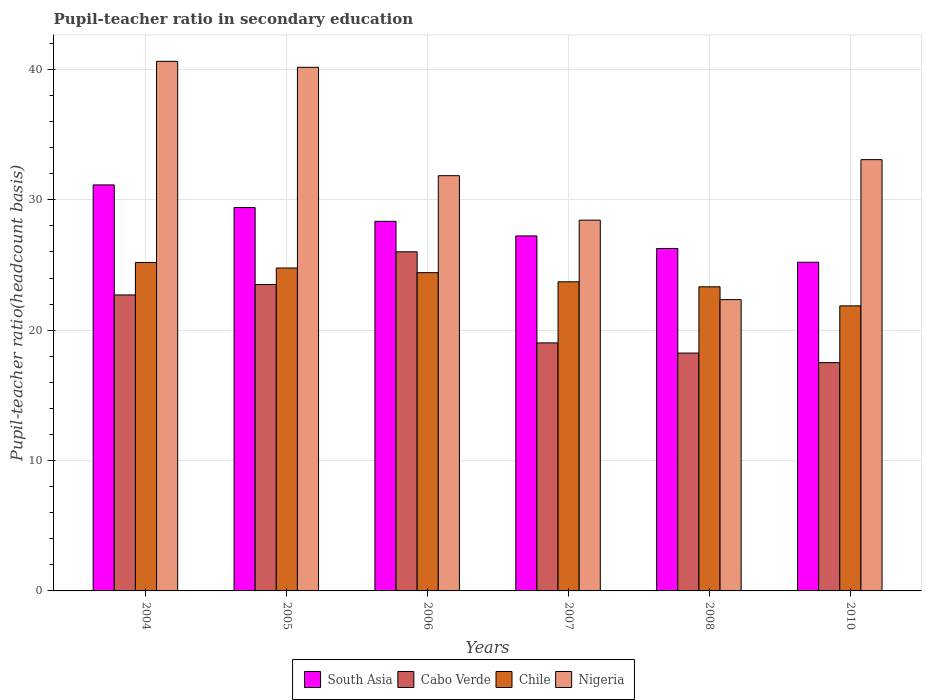How many groups of bars are there?
Offer a terse response. 6. Are the number of bars per tick equal to the number of legend labels?
Your response must be concise. Yes. Are the number of bars on each tick of the X-axis equal?
Your answer should be compact. Yes. How many bars are there on the 3rd tick from the left?
Your answer should be compact. 4. How many bars are there on the 3rd tick from the right?
Your answer should be compact. 4. What is the pupil-teacher ratio in secondary education in Cabo Verde in 2006?
Your answer should be very brief. 26.01. Across all years, what is the maximum pupil-teacher ratio in secondary education in Cabo Verde?
Your answer should be very brief. 26.01. Across all years, what is the minimum pupil-teacher ratio in secondary education in Chile?
Make the answer very short. 21.87. In which year was the pupil-teacher ratio in secondary education in South Asia maximum?
Provide a short and direct response. 2004. What is the total pupil-teacher ratio in secondary education in Chile in the graph?
Offer a very short reply. 143.28. What is the difference between the pupil-teacher ratio in secondary education in Nigeria in 2006 and that in 2008?
Make the answer very short. 9.51. What is the difference between the pupil-teacher ratio in secondary education in Nigeria in 2007 and the pupil-teacher ratio in secondary education in Cabo Verde in 2005?
Give a very brief answer. 4.94. What is the average pupil-teacher ratio in secondary education in Nigeria per year?
Your answer should be compact. 32.75. In the year 2004, what is the difference between the pupil-teacher ratio in secondary education in Chile and pupil-teacher ratio in secondary education in Nigeria?
Your answer should be compact. -15.43. In how many years, is the pupil-teacher ratio in secondary education in Nigeria greater than 38?
Offer a very short reply. 2. What is the ratio of the pupil-teacher ratio in secondary education in Cabo Verde in 2005 to that in 2006?
Offer a very short reply. 0.9. Is the pupil-teacher ratio in secondary education in South Asia in 2006 less than that in 2007?
Ensure brevity in your answer.  No. Is the difference between the pupil-teacher ratio in secondary education in Chile in 2006 and 2008 greater than the difference between the pupil-teacher ratio in secondary education in Nigeria in 2006 and 2008?
Provide a short and direct response. No. What is the difference between the highest and the second highest pupil-teacher ratio in secondary education in Cabo Verde?
Keep it short and to the point. 2.51. What is the difference between the highest and the lowest pupil-teacher ratio in secondary education in Chile?
Your answer should be compact. 3.33. What does the 4th bar from the left in 2010 represents?
Your response must be concise. Nigeria. Is it the case that in every year, the sum of the pupil-teacher ratio in secondary education in South Asia and pupil-teacher ratio in secondary education in Cabo Verde is greater than the pupil-teacher ratio in secondary education in Chile?
Keep it short and to the point. Yes. How many bars are there?
Give a very brief answer. 24. Are all the bars in the graph horizontal?
Provide a short and direct response. No. What is the difference between two consecutive major ticks on the Y-axis?
Keep it short and to the point. 10. Are the values on the major ticks of Y-axis written in scientific E-notation?
Provide a succinct answer. No. Does the graph contain grids?
Make the answer very short. Yes. Where does the legend appear in the graph?
Offer a very short reply. Bottom center. How many legend labels are there?
Your answer should be very brief. 4. How are the legend labels stacked?
Give a very brief answer. Horizontal. What is the title of the graph?
Ensure brevity in your answer.  Pupil-teacher ratio in secondary education. Does "Estonia" appear as one of the legend labels in the graph?
Make the answer very short. No. What is the label or title of the Y-axis?
Keep it short and to the point. Pupil-teacher ratio(headcount basis). What is the Pupil-teacher ratio(headcount basis) of South Asia in 2004?
Give a very brief answer. 31.14. What is the Pupil-teacher ratio(headcount basis) of Cabo Verde in 2004?
Make the answer very short. 22.7. What is the Pupil-teacher ratio(headcount basis) in Chile in 2004?
Your answer should be compact. 25.19. What is the Pupil-teacher ratio(headcount basis) of Nigeria in 2004?
Offer a very short reply. 40.62. What is the Pupil-teacher ratio(headcount basis) in South Asia in 2005?
Your answer should be compact. 29.41. What is the Pupil-teacher ratio(headcount basis) of Cabo Verde in 2005?
Your answer should be compact. 23.5. What is the Pupil-teacher ratio(headcount basis) in Chile in 2005?
Your response must be concise. 24.77. What is the Pupil-teacher ratio(headcount basis) of Nigeria in 2005?
Provide a succinct answer. 40.16. What is the Pupil-teacher ratio(headcount basis) of South Asia in 2006?
Offer a terse response. 28.35. What is the Pupil-teacher ratio(headcount basis) in Cabo Verde in 2006?
Your response must be concise. 26.01. What is the Pupil-teacher ratio(headcount basis) of Chile in 2006?
Offer a very short reply. 24.41. What is the Pupil-teacher ratio(headcount basis) in Nigeria in 2006?
Make the answer very short. 31.85. What is the Pupil-teacher ratio(headcount basis) in South Asia in 2007?
Make the answer very short. 27.23. What is the Pupil-teacher ratio(headcount basis) in Cabo Verde in 2007?
Ensure brevity in your answer.  19.02. What is the Pupil-teacher ratio(headcount basis) of Chile in 2007?
Provide a short and direct response. 23.71. What is the Pupil-teacher ratio(headcount basis) in Nigeria in 2007?
Your answer should be compact. 28.44. What is the Pupil-teacher ratio(headcount basis) of South Asia in 2008?
Your answer should be very brief. 26.26. What is the Pupil-teacher ratio(headcount basis) of Cabo Verde in 2008?
Offer a terse response. 18.25. What is the Pupil-teacher ratio(headcount basis) in Chile in 2008?
Ensure brevity in your answer.  23.33. What is the Pupil-teacher ratio(headcount basis) of Nigeria in 2008?
Make the answer very short. 22.34. What is the Pupil-teacher ratio(headcount basis) of South Asia in 2010?
Offer a terse response. 25.21. What is the Pupil-teacher ratio(headcount basis) in Cabo Verde in 2010?
Keep it short and to the point. 17.51. What is the Pupil-teacher ratio(headcount basis) in Chile in 2010?
Provide a succinct answer. 21.87. What is the Pupil-teacher ratio(headcount basis) of Nigeria in 2010?
Make the answer very short. 33.08. Across all years, what is the maximum Pupil-teacher ratio(headcount basis) of South Asia?
Offer a very short reply. 31.14. Across all years, what is the maximum Pupil-teacher ratio(headcount basis) of Cabo Verde?
Make the answer very short. 26.01. Across all years, what is the maximum Pupil-teacher ratio(headcount basis) in Chile?
Your response must be concise. 25.19. Across all years, what is the maximum Pupil-teacher ratio(headcount basis) of Nigeria?
Ensure brevity in your answer.  40.62. Across all years, what is the minimum Pupil-teacher ratio(headcount basis) of South Asia?
Provide a short and direct response. 25.21. Across all years, what is the minimum Pupil-teacher ratio(headcount basis) of Cabo Verde?
Your answer should be very brief. 17.51. Across all years, what is the minimum Pupil-teacher ratio(headcount basis) in Chile?
Offer a very short reply. 21.87. Across all years, what is the minimum Pupil-teacher ratio(headcount basis) of Nigeria?
Offer a terse response. 22.34. What is the total Pupil-teacher ratio(headcount basis) of South Asia in the graph?
Offer a terse response. 167.6. What is the total Pupil-teacher ratio(headcount basis) in Cabo Verde in the graph?
Make the answer very short. 127. What is the total Pupil-teacher ratio(headcount basis) in Chile in the graph?
Your answer should be compact. 143.28. What is the total Pupil-teacher ratio(headcount basis) of Nigeria in the graph?
Your response must be concise. 196.5. What is the difference between the Pupil-teacher ratio(headcount basis) of South Asia in 2004 and that in 2005?
Your response must be concise. 1.74. What is the difference between the Pupil-teacher ratio(headcount basis) in Cabo Verde in 2004 and that in 2005?
Keep it short and to the point. -0.8. What is the difference between the Pupil-teacher ratio(headcount basis) of Chile in 2004 and that in 2005?
Your response must be concise. 0.42. What is the difference between the Pupil-teacher ratio(headcount basis) of Nigeria in 2004 and that in 2005?
Provide a short and direct response. 0.45. What is the difference between the Pupil-teacher ratio(headcount basis) in South Asia in 2004 and that in 2006?
Your answer should be compact. 2.79. What is the difference between the Pupil-teacher ratio(headcount basis) of Cabo Verde in 2004 and that in 2006?
Ensure brevity in your answer.  -3.31. What is the difference between the Pupil-teacher ratio(headcount basis) of Chile in 2004 and that in 2006?
Your response must be concise. 0.78. What is the difference between the Pupil-teacher ratio(headcount basis) of Nigeria in 2004 and that in 2006?
Your answer should be very brief. 8.77. What is the difference between the Pupil-teacher ratio(headcount basis) in South Asia in 2004 and that in 2007?
Your response must be concise. 3.91. What is the difference between the Pupil-teacher ratio(headcount basis) of Cabo Verde in 2004 and that in 2007?
Give a very brief answer. 3.68. What is the difference between the Pupil-teacher ratio(headcount basis) of Chile in 2004 and that in 2007?
Make the answer very short. 1.48. What is the difference between the Pupil-teacher ratio(headcount basis) of Nigeria in 2004 and that in 2007?
Keep it short and to the point. 12.18. What is the difference between the Pupil-teacher ratio(headcount basis) of South Asia in 2004 and that in 2008?
Provide a short and direct response. 4.88. What is the difference between the Pupil-teacher ratio(headcount basis) in Cabo Verde in 2004 and that in 2008?
Your answer should be compact. 4.46. What is the difference between the Pupil-teacher ratio(headcount basis) in Chile in 2004 and that in 2008?
Ensure brevity in your answer.  1.87. What is the difference between the Pupil-teacher ratio(headcount basis) of Nigeria in 2004 and that in 2008?
Give a very brief answer. 18.28. What is the difference between the Pupil-teacher ratio(headcount basis) in South Asia in 2004 and that in 2010?
Provide a short and direct response. 5.93. What is the difference between the Pupil-teacher ratio(headcount basis) in Cabo Verde in 2004 and that in 2010?
Your answer should be compact. 5.19. What is the difference between the Pupil-teacher ratio(headcount basis) of Chile in 2004 and that in 2010?
Ensure brevity in your answer.  3.33. What is the difference between the Pupil-teacher ratio(headcount basis) in Nigeria in 2004 and that in 2010?
Keep it short and to the point. 7.54. What is the difference between the Pupil-teacher ratio(headcount basis) of South Asia in 2005 and that in 2006?
Ensure brevity in your answer.  1.06. What is the difference between the Pupil-teacher ratio(headcount basis) of Cabo Verde in 2005 and that in 2006?
Your answer should be compact. -2.51. What is the difference between the Pupil-teacher ratio(headcount basis) in Chile in 2005 and that in 2006?
Keep it short and to the point. 0.36. What is the difference between the Pupil-teacher ratio(headcount basis) in Nigeria in 2005 and that in 2006?
Your answer should be very brief. 8.31. What is the difference between the Pupil-teacher ratio(headcount basis) in South Asia in 2005 and that in 2007?
Your answer should be very brief. 2.18. What is the difference between the Pupil-teacher ratio(headcount basis) of Cabo Verde in 2005 and that in 2007?
Your answer should be very brief. 4.48. What is the difference between the Pupil-teacher ratio(headcount basis) of Chile in 2005 and that in 2007?
Keep it short and to the point. 1.06. What is the difference between the Pupil-teacher ratio(headcount basis) in Nigeria in 2005 and that in 2007?
Your answer should be very brief. 11.72. What is the difference between the Pupil-teacher ratio(headcount basis) in South Asia in 2005 and that in 2008?
Make the answer very short. 3.14. What is the difference between the Pupil-teacher ratio(headcount basis) of Cabo Verde in 2005 and that in 2008?
Ensure brevity in your answer.  5.26. What is the difference between the Pupil-teacher ratio(headcount basis) of Chile in 2005 and that in 2008?
Your answer should be compact. 1.44. What is the difference between the Pupil-teacher ratio(headcount basis) in Nigeria in 2005 and that in 2008?
Provide a succinct answer. 17.82. What is the difference between the Pupil-teacher ratio(headcount basis) of South Asia in 2005 and that in 2010?
Your answer should be compact. 4.2. What is the difference between the Pupil-teacher ratio(headcount basis) in Cabo Verde in 2005 and that in 2010?
Offer a very short reply. 5.99. What is the difference between the Pupil-teacher ratio(headcount basis) of Chile in 2005 and that in 2010?
Make the answer very short. 2.9. What is the difference between the Pupil-teacher ratio(headcount basis) of Nigeria in 2005 and that in 2010?
Ensure brevity in your answer.  7.08. What is the difference between the Pupil-teacher ratio(headcount basis) in South Asia in 2006 and that in 2007?
Offer a very short reply. 1.12. What is the difference between the Pupil-teacher ratio(headcount basis) of Cabo Verde in 2006 and that in 2007?
Give a very brief answer. 6.99. What is the difference between the Pupil-teacher ratio(headcount basis) of Chile in 2006 and that in 2007?
Make the answer very short. 0.7. What is the difference between the Pupil-teacher ratio(headcount basis) of Nigeria in 2006 and that in 2007?
Keep it short and to the point. 3.41. What is the difference between the Pupil-teacher ratio(headcount basis) in South Asia in 2006 and that in 2008?
Provide a short and direct response. 2.08. What is the difference between the Pupil-teacher ratio(headcount basis) in Cabo Verde in 2006 and that in 2008?
Give a very brief answer. 7.77. What is the difference between the Pupil-teacher ratio(headcount basis) of Chile in 2006 and that in 2008?
Provide a short and direct response. 1.09. What is the difference between the Pupil-teacher ratio(headcount basis) in Nigeria in 2006 and that in 2008?
Your response must be concise. 9.51. What is the difference between the Pupil-teacher ratio(headcount basis) of South Asia in 2006 and that in 2010?
Give a very brief answer. 3.14. What is the difference between the Pupil-teacher ratio(headcount basis) of Cabo Verde in 2006 and that in 2010?
Keep it short and to the point. 8.5. What is the difference between the Pupil-teacher ratio(headcount basis) of Chile in 2006 and that in 2010?
Provide a short and direct response. 2.55. What is the difference between the Pupil-teacher ratio(headcount basis) of Nigeria in 2006 and that in 2010?
Ensure brevity in your answer.  -1.23. What is the difference between the Pupil-teacher ratio(headcount basis) in South Asia in 2007 and that in 2008?
Offer a terse response. 0.97. What is the difference between the Pupil-teacher ratio(headcount basis) of Cabo Verde in 2007 and that in 2008?
Your answer should be very brief. 0.78. What is the difference between the Pupil-teacher ratio(headcount basis) in Chile in 2007 and that in 2008?
Keep it short and to the point. 0.38. What is the difference between the Pupil-teacher ratio(headcount basis) of Nigeria in 2007 and that in 2008?
Your response must be concise. 6.1. What is the difference between the Pupil-teacher ratio(headcount basis) of South Asia in 2007 and that in 2010?
Make the answer very short. 2.02. What is the difference between the Pupil-teacher ratio(headcount basis) of Cabo Verde in 2007 and that in 2010?
Your response must be concise. 1.51. What is the difference between the Pupil-teacher ratio(headcount basis) of Chile in 2007 and that in 2010?
Make the answer very short. 1.85. What is the difference between the Pupil-teacher ratio(headcount basis) in Nigeria in 2007 and that in 2010?
Make the answer very short. -4.64. What is the difference between the Pupil-teacher ratio(headcount basis) of South Asia in 2008 and that in 2010?
Your response must be concise. 1.05. What is the difference between the Pupil-teacher ratio(headcount basis) of Cabo Verde in 2008 and that in 2010?
Provide a short and direct response. 0.73. What is the difference between the Pupil-teacher ratio(headcount basis) in Chile in 2008 and that in 2010?
Your response must be concise. 1.46. What is the difference between the Pupil-teacher ratio(headcount basis) in Nigeria in 2008 and that in 2010?
Your answer should be very brief. -10.74. What is the difference between the Pupil-teacher ratio(headcount basis) in South Asia in 2004 and the Pupil-teacher ratio(headcount basis) in Cabo Verde in 2005?
Your answer should be compact. 7.64. What is the difference between the Pupil-teacher ratio(headcount basis) of South Asia in 2004 and the Pupil-teacher ratio(headcount basis) of Chile in 2005?
Offer a very short reply. 6.37. What is the difference between the Pupil-teacher ratio(headcount basis) in South Asia in 2004 and the Pupil-teacher ratio(headcount basis) in Nigeria in 2005?
Offer a terse response. -9.02. What is the difference between the Pupil-teacher ratio(headcount basis) in Cabo Verde in 2004 and the Pupil-teacher ratio(headcount basis) in Chile in 2005?
Provide a short and direct response. -2.06. What is the difference between the Pupil-teacher ratio(headcount basis) of Cabo Verde in 2004 and the Pupil-teacher ratio(headcount basis) of Nigeria in 2005?
Your answer should be compact. -17.46. What is the difference between the Pupil-teacher ratio(headcount basis) of Chile in 2004 and the Pupil-teacher ratio(headcount basis) of Nigeria in 2005?
Make the answer very short. -14.97. What is the difference between the Pupil-teacher ratio(headcount basis) of South Asia in 2004 and the Pupil-teacher ratio(headcount basis) of Cabo Verde in 2006?
Ensure brevity in your answer.  5.13. What is the difference between the Pupil-teacher ratio(headcount basis) of South Asia in 2004 and the Pupil-teacher ratio(headcount basis) of Chile in 2006?
Ensure brevity in your answer.  6.73. What is the difference between the Pupil-teacher ratio(headcount basis) of South Asia in 2004 and the Pupil-teacher ratio(headcount basis) of Nigeria in 2006?
Offer a very short reply. -0.71. What is the difference between the Pupil-teacher ratio(headcount basis) in Cabo Verde in 2004 and the Pupil-teacher ratio(headcount basis) in Chile in 2006?
Your response must be concise. -1.71. What is the difference between the Pupil-teacher ratio(headcount basis) in Cabo Verde in 2004 and the Pupil-teacher ratio(headcount basis) in Nigeria in 2006?
Give a very brief answer. -9.15. What is the difference between the Pupil-teacher ratio(headcount basis) of Chile in 2004 and the Pupil-teacher ratio(headcount basis) of Nigeria in 2006?
Your answer should be compact. -6.66. What is the difference between the Pupil-teacher ratio(headcount basis) of South Asia in 2004 and the Pupil-teacher ratio(headcount basis) of Cabo Verde in 2007?
Your answer should be very brief. 12.12. What is the difference between the Pupil-teacher ratio(headcount basis) in South Asia in 2004 and the Pupil-teacher ratio(headcount basis) in Chile in 2007?
Your answer should be compact. 7.43. What is the difference between the Pupil-teacher ratio(headcount basis) in South Asia in 2004 and the Pupil-teacher ratio(headcount basis) in Nigeria in 2007?
Make the answer very short. 2.7. What is the difference between the Pupil-teacher ratio(headcount basis) of Cabo Verde in 2004 and the Pupil-teacher ratio(headcount basis) of Chile in 2007?
Ensure brevity in your answer.  -1.01. What is the difference between the Pupil-teacher ratio(headcount basis) of Cabo Verde in 2004 and the Pupil-teacher ratio(headcount basis) of Nigeria in 2007?
Your response must be concise. -5.74. What is the difference between the Pupil-teacher ratio(headcount basis) of Chile in 2004 and the Pupil-teacher ratio(headcount basis) of Nigeria in 2007?
Keep it short and to the point. -3.25. What is the difference between the Pupil-teacher ratio(headcount basis) in South Asia in 2004 and the Pupil-teacher ratio(headcount basis) in Cabo Verde in 2008?
Provide a short and direct response. 12.9. What is the difference between the Pupil-teacher ratio(headcount basis) in South Asia in 2004 and the Pupil-teacher ratio(headcount basis) in Chile in 2008?
Ensure brevity in your answer.  7.82. What is the difference between the Pupil-teacher ratio(headcount basis) in South Asia in 2004 and the Pupil-teacher ratio(headcount basis) in Nigeria in 2008?
Make the answer very short. 8.8. What is the difference between the Pupil-teacher ratio(headcount basis) of Cabo Verde in 2004 and the Pupil-teacher ratio(headcount basis) of Chile in 2008?
Your answer should be very brief. -0.62. What is the difference between the Pupil-teacher ratio(headcount basis) of Cabo Verde in 2004 and the Pupil-teacher ratio(headcount basis) of Nigeria in 2008?
Offer a very short reply. 0.36. What is the difference between the Pupil-teacher ratio(headcount basis) of Chile in 2004 and the Pupil-teacher ratio(headcount basis) of Nigeria in 2008?
Provide a succinct answer. 2.85. What is the difference between the Pupil-teacher ratio(headcount basis) of South Asia in 2004 and the Pupil-teacher ratio(headcount basis) of Cabo Verde in 2010?
Keep it short and to the point. 13.63. What is the difference between the Pupil-teacher ratio(headcount basis) in South Asia in 2004 and the Pupil-teacher ratio(headcount basis) in Chile in 2010?
Ensure brevity in your answer.  9.28. What is the difference between the Pupil-teacher ratio(headcount basis) in South Asia in 2004 and the Pupil-teacher ratio(headcount basis) in Nigeria in 2010?
Provide a succinct answer. -1.94. What is the difference between the Pupil-teacher ratio(headcount basis) in Cabo Verde in 2004 and the Pupil-teacher ratio(headcount basis) in Chile in 2010?
Your answer should be compact. 0.84. What is the difference between the Pupil-teacher ratio(headcount basis) in Cabo Verde in 2004 and the Pupil-teacher ratio(headcount basis) in Nigeria in 2010?
Keep it short and to the point. -10.38. What is the difference between the Pupil-teacher ratio(headcount basis) of Chile in 2004 and the Pupil-teacher ratio(headcount basis) of Nigeria in 2010?
Your answer should be very brief. -7.89. What is the difference between the Pupil-teacher ratio(headcount basis) of South Asia in 2005 and the Pupil-teacher ratio(headcount basis) of Cabo Verde in 2006?
Give a very brief answer. 3.39. What is the difference between the Pupil-teacher ratio(headcount basis) in South Asia in 2005 and the Pupil-teacher ratio(headcount basis) in Chile in 2006?
Ensure brevity in your answer.  4.99. What is the difference between the Pupil-teacher ratio(headcount basis) of South Asia in 2005 and the Pupil-teacher ratio(headcount basis) of Nigeria in 2006?
Your answer should be compact. -2.44. What is the difference between the Pupil-teacher ratio(headcount basis) in Cabo Verde in 2005 and the Pupil-teacher ratio(headcount basis) in Chile in 2006?
Ensure brevity in your answer.  -0.91. What is the difference between the Pupil-teacher ratio(headcount basis) in Cabo Verde in 2005 and the Pupil-teacher ratio(headcount basis) in Nigeria in 2006?
Your answer should be compact. -8.35. What is the difference between the Pupil-teacher ratio(headcount basis) in Chile in 2005 and the Pupil-teacher ratio(headcount basis) in Nigeria in 2006?
Your answer should be compact. -7.08. What is the difference between the Pupil-teacher ratio(headcount basis) of South Asia in 2005 and the Pupil-teacher ratio(headcount basis) of Cabo Verde in 2007?
Give a very brief answer. 10.38. What is the difference between the Pupil-teacher ratio(headcount basis) of South Asia in 2005 and the Pupil-teacher ratio(headcount basis) of Chile in 2007?
Ensure brevity in your answer.  5.69. What is the difference between the Pupil-teacher ratio(headcount basis) of South Asia in 2005 and the Pupil-teacher ratio(headcount basis) of Nigeria in 2007?
Keep it short and to the point. 0.97. What is the difference between the Pupil-teacher ratio(headcount basis) of Cabo Verde in 2005 and the Pupil-teacher ratio(headcount basis) of Chile in 2007?
Your answer should be very brief. -0.21. What is the difference between the Pupil-teacher ratio(headcount basis) in Cabo Verde in 2005 and the Pupil-teacher ratio(headcount basis) in Nigeria in 2007?
Keep it short and to the point. -4.94. What is the difference between the Pupil-teacher ratio(headcount basis) in Chile in 2005 and the Pupil-teacher ratio(headcount basis) in Nigeria in 2007?
Offer a very short reply. -3.67. What is the difference between the Pupil-teacher ratio(headcount basis) of South Asia in 2005 and the Pupil-teacher ratio(headcount basis) of Cabo Verde in 2008?
Provide a succinct answer. 11.16. What is the difference between the Pupil-teacher ratio(headcount basis) of South Asia in 2005 and the Pupil-teacher ratio(headcount basis) of Chile in 2008?
Make the answer very short. 6.08. What is the difference between the Pupil-teacher ratio(headcount basis) of South Asia in 2005 and the Pupil-teacher ratio(headcount basis) of Nigeria in 2008?
Your answer should be compact. 7.06. What is the difference between the Pupil-teacher ratio(headcount basis) in Cabo Verde in 2005 and the Pupil-teacher ratio(headcount basis) in Chile in 2008?
Make the answer very short. 0.18. What is the difference between the Pupil-teacher ratio(headcount basis) of Cabo Verde in 2005 and the Pupil-teacher ratio(headcount basis) of Nigeria in 2008?
Ensure brevity in your answer.  1.16. What is the difference between the Pupil-teacher ratio(headcount basis) of Chile in 2005 and the Pupil-teacher ratio(headcount basis) of Nigeria in 2008?
Give a very brief answer. 2.43. What is the difference between the Pupil-teacher ratio(headcount basis) in South Asia in 2005 and the Pupil-teacher ratio(headcount basis) in Cabo Verde in 2010?
Offer a terse response. 11.89. What is the difference between the Pupil-teacher ratio(headcount basis) in South Asia in 2005 and the Pupil-teacher ratio(headcount basis) in Chile in 2010?
Provide a succinct answer. 7.54. What is the difference between the Pupil-teacher ratio(headcount basis) of South Asia in 2005 and the Pupil-teacher ratio(headcount basis) of Nigeria in 2010?
Offer a very short reply. -3.67. What is the difference between the Pupil-teacher ratio(headcount basis) of Cabo Verde in 2005 and the Pupil-teacher ratio(headcount basis) of Chile in 2010?
Provide a succinct answer. 1.64. What is the difference between the Pupil-teacher ratio(headcount basis) of Cabo Verde in 2005 and the Pupil-teacher ratio(headcount basis) of Nigeria in 2010?
Make the answer very short. -9.58. What is the difference between the Pupil-teacher ratio(headcount basis) in Chile in 2005 and the Pupil-teacher ratio(headcount basis) in Nigeria in 2010?
Your answer should be very brief. -8.31. What is the difference between the Pupil-teacher ratio(headcount basis) of South Asia in 2006 and the Pupil-teacher ratio(headcount basis) of Cabo Verde in 2007?
Ensure brevity in your answer.  9.32. What is the difference between the Pupil-teacher ratio(headcount basis) in South Asia in 2006 and the Pupil-teacher ratio(headcount basis) in Chile in 2007?
Keep it short and to the point. 4.64. What is the difference between the Pupil-teacher ratio(headcount basis) in South Asia in 2006 and the Pupil-teacher ratio(headcount basis) in Nigeria in 2007?
Give a very brief answer. -0.09. What is the difference between the Pupil-teacher ratio(headcount basis) in Cabo Verde in 2006 and the Pupil-teacher ratio(headcount basis) in Chile in 2007?
Your response must be concise. 2.3. What is the difference between the Pupil-teacher ratio(headcount basis) of Cabo Verde in 2006 and the Pupil-teacher ratio(headcount basis) of Nigeria in 2007?
Provide a short and direct response. -2.43. What is the difference between the Pupil-teacher ratio(headcount basis) of Chile in 2006 and the Pupil-teacher ratio(headcount basis) of Nigeria in 2007?
Keep it short and to the point. -4.03. What is the difference between the Pupil-teacher ratio(headcount basis) of South Asia in 2006 and the Pupil-teacher ratio(headcount basis) of Cabo Verde in 2008?
Give a very brief answer. 10.1. What is the difference between the Pupil-teacher ratio(headcount basis) in South Asia in 2006 and the Pupil-teacher ratio(headcount basis) in Chile in 2008?
Keep it short and to the point. 5.02. What is the difference between the Pupil-teacher ratio(headcount basis) in South Asia in 2006 and the Pupil-teacher ratio(headcount basis) in Nigeria in 2008?
Your answer should be very brief. 6.01. What is the difference between the Pupil-teacher ratio(headcount basis) of Cabo Verde in 2006 and the Pupil-teacher ratio(headcount basis) of Chile in 2008?
Keep it short and to the point. 2.69. What is the difference between the Pupil-teacher ratio(headcount basis) in Cabo Verde in 2006 and the Pupil-teacher ratio(headcount basis) in Nigeria in 2008?
Give a very brief answer. 3.67. What is the difference between the Pupil-teacher ratio(headcount basis) of Chile in 2006 and the Pupil-teacher ratio(headcount basis) of Nigeria in 2008?
Keep it short and to the point. 2.07. What is the difference between the Pupil-teacher ratio(headcount basis) of South Asia in 2006 and the Pupil-teacher ratio(headcount basis) of Cabo Verde in 2010?
Ensure brevity in your answer.  10.84. What is the difference between the Pupil-teacher ratio(headcount basis) of South Asia in 2006 and the Pupil-teacher ratio(headcount basis) of Chile in 2010?
Offer a very short reply. 6.48. What is the difference between the Pupil-teacher ratio(headcount basis) in South Asia in 2006 and the Pupil-teacher ratio(headcount basis) in Nigeria in 2010?
Offer a terse response. -4.73. What is the difference between the Pupil-teacher ratio(headcount basis) of Cabo Verde in 2006 and the Pupil-teacher ratio(headcount basis) of Chile in 2010?
Offer a terse response. 4.15. What is the difference between the Pupil-teacher ratio(headcount basis) in Cabo Verde in 2006 and the Pupil-teacher ratio(headcount basis) in Nigeria in 2010?
Your response must be concise. -7.07. What is the difference between the Pupil-teacher ratio(headcount basis) of Chile in 2006 and the Pupil-teacher ratio(headcount basis) of Nigeria in 2010?
Your answer should be very brief. -8.67. What is the difference between the Pupil-teacher ratio(headcount basis) in South Asia in 2007 and the Pupil-teacher ratio(headcount basis) in Cabo Verde in 2008?
Your answer should be compact. 8.99. What is the difference between the Pupil-teacher ratio(headcount basis) in South Asia in 2007 and the Pupil-teacher ratio(headcount basis) in Chile in 2008?
Provide a short and direct response. 3.9. What is the difference between the Pupil-teacher ratio(headcount basis) of South Asia in 2007 and the Pupil-teacher ratio(headcount basis) of Nigeria in 2008?
Provide a short and direct response. 4.89. What is the difference between the Pupil-teacher ratio(headcount basis) in Cabo Verde in 2007 and the Pupil-teacher ratio(headcount basis) in Chile in 2008?
Provide a short and direct response. -4.3. What is the difference between the Pupil-teacher ratio(headcount basis) of Cabo Verde in 2007 and the Pupil-teacher ratio(headcount basis) of Nigeria in 2008?
Make the answer very short. -3.32. What is the difference between the Pupil-teacher ratio(headcount basis) in Chile in 2007 and the Pupil-teacher ratio(headcount basis) in Nigeria in 2008?
Offer a terse response. 1.37. What is the difference between the Pupil-teacher ratio(headcount basis) in South Asia in 2007 and the Pupil-teacher ratio(headcount basis) in Cabo Verde in 2010?
Offer a terse response. 9.72. What is the difference between the Pupil-teacher ratio(headcount basis) in South Asia in 2007 and the Pupil-teacher ratio(headcount basis) in Chile in 2010?
Offer a very short reply. 5.36. What is the difference between the Pupil-teacher ratio(headcount basis) in South Asia in 2007 and the Pupil-teacher ratio(headcount basis) in Nigeria in 2010?
Make the answer very short. -5.85. What is the difference between the Pupil-teacher ratio(headcount basis) in Cabo Verde in 2007 and the Pupil-teacher ratio(headcount basis) in Chile in 2010?
Offer a terse response. -2.84. What is the difference between the Pupil-teacher ratio(headcount basis) of Cabo Verde in 2007 and the Pupil-teacher ratio(headcount basis) of Nigeria in 2010?
Keep it short and to the point. -14.06. What is the difference between the Pupil-teacher ratio(headcount basis) of Chile in 2007 and the Pupil-teacher ratio(headcount basis) of Nigeria in 2010?
Your response must be concise. -9.37. What is the difference between the Pupil-teacher ratio(headcount basis) in South Asia in 2008 and the Pupil-teacher ratio(headcount basis) in Cabo Verde in 2010?
Make the answer very short. 8.75. What is the difference between the Pupil-teacher ratio(headcount basis) of South Asia in 2008 and the Pupil-teacher ratio(headcount basis) of Chile in 2010?
Offer a very short reply. 4.4. What is the difference between the Pupil-teacher ratio(headcount basis) of South Asia in 2008 and the Pupil-teacher ratio(headcount basis) of Nigeria in 2010?
Your answer should be compact. -6.82. What is the difference between the Pupil-teacher ratio(headcount basis) of Cabo Verde in 2008 and the Pupil-teacher ratio(headcount basis) of Chile in 2010?
Give a very brief answer. -3.62. What is the difference between the Pupil-teacher ratio(headcount basis) in Cabo Verde in 2008 and the Pupil-teacher ratio(headcount basis) in Nigeria in 2010?
Make the answer very short. -14.84. What is the difference between the Pupil-teacher ratio(headcount basis) in Chile in 2008 and the Pupil-teacher ratio(headcount basis) in Nigeria in 2010?
Make the answer very short. -9.75. What is the average Pupil-teacher ratio(headcount basis) in South Asia per year?
Make the answer very short. 27.93. What is the average Pupil-teacher ratio(headcount basis) of Cabo Verde per year?
Give a very brief answer. 21.17. What is the average Pupil-teacher ratio(headcount basis) of Chile per year?
Your answer should be very brief. 23.88. What is the average Pupil-teacher ratio(headcount basis) of Nigeria per year?
Make the answer very short. 32.75. In the year 2004, what is the difference between the Pupil-teacher ratio(headcount basis) in South Asia and Pupil-teacher ratio(headcount basis) in Cabo Verde?
Give a very brief answer. 8.44. In the year 2004, what is the difference between the Pupil-teacher ratio(headcount basis) of South Asia and Pupil-teacher ratio(headcount basis) of Chile?
Make the answer very short. 5.95. In the year 2004, what is the difference between the Pupil-teacher ratio(headcount basis) in South Asia and Pupil-teacher ratio(headcount basis) in Nigeria?
Offer a terse response. -9.48. In the year 2004, what is the difference between the Pupil-teacher ratio(headcount basis) in Cabo Verde and Pupil-teacher ratio(headcount basis) in Chile?
Keep it short and to the point. -2.49. In the year 2004, what is the difference between the Pupil-teacher ratio(headcount basis) of Cabo Verde and Pupil-teacher ratio(headcount basis) of Nigeria?
Ensure brevity in your answer.  -17.92. In the year 2004, what is the difference between the Pupil-teacher ratio(headcount basis) in Chile and Pupil-teacher ratio(headcount basis) in Nigeria?
Your answer should be compact. -15.43. In the year 2005, what is the difference between the Pupil-teacher ratio(headcount basis) of South Asia and Pupil-teacher ratio(headcount basis) of Cabo Verde?
Your answer should be compact. 5.9. In the year 2005, what is the difference between the Pupil-teacher ratio(headcount basis) in South Asia and Pupil-teacher ratio(headcount basis) in Chile?
Your answer should be very brief. 4.64. In the year 2005, what is the difference between the Pupil-teacher ratio(headcount basis) in South Asia and Pupil-teacher ratio(headcount basis) in Nigeria?
Make the answer very short. -10.76. In the year 2005, what is the difference between the Pupil-teacher ratio(headcount basis) in Cabo Verde and Pupil-teacher ratio(headcount basis) in Chile?
Offer a terse response. -1.27. In the year 2005, what is the difference between the Pupil-teacher ratio(headcount basis) in Cabo Verde and Pupil-teacher ratio(headcount basis) in Nigeria?
Offer a very short reply. -16.66. In the year 2005, what is the difference between the Pupil-teacher ratio(headcount basis) in Chile and Pupil-teacher ratio(headcount basis) in Nigeria?
Make the answer very short. -15.4. In the year 2006, what is the difference between the Pupil-teacher ratio(headcount basis) in South Asia and Pupil-teacher ratio(headcount basis) in Cabo Verde?
Offer a very short reply. 2.34. In the year 2006, what is the difference between the Pupil-teacher ratio(headcount basis) of South Asia and Pupil-teacher ratio(headcount basis) of Chile?
Your answer should be compact. 3.94. In the year 2006, what is the difference between the Pupil-teacher ratio(headcount basis) in South Asia and Pupil-teacher ratio(headcount basis) in Nigeria?
Offer a terse response. -3.5. In the year 2006, what is the difference between the Pupil-teacher ratio(headcount basis) of Cabo Verde and Pupil-teacher ratio(headcount basis) of Chile?
Offer a terse response. 1.6. In the year 2006, what is the difference between the Pupil-teacher ratio(headcount basis) in Cabo Verde and Pupil-teacher ratio(headcount basis) in Nigeria?
Ensure brevity in your answer.  -5.84. In the year 2006, what is the difference between the Pupil-teacher ratio(headcount basis) in Chile and Pupil-teacher ratio(headcount basis) in Nigeria?
Offer a terse response. -7.44. In the year 2007, what is the difference between the Pupil-teacher ratio(headcount basis) in South Asia and Pupil-teacher ratio(headcount basis) in Cabo Verde?
Your answer should be very brief. 8.21. In the year 2007, what is the difference between the Pupil-teacher ratio(headcount basis) in South Asia and Pupil-teacher ratio(headcount basis) in Chile?
Give a very brief answer. 3.52. In the year 2007, what is the difference between the Pupil-teacher ratio(headcount basis) in South Asia and Pupil-teacher ratio(headcount basis) in Nigeria?
Your response must be concise. -1.21. In the year 2007, what is the difference between the Pupil-teacher ratio(headcount basis) of Cabo Verde and Pupil-teacher ratio(headcount basis) of Chile?
Your response must be concise. -4.69. In the year 2007, what is the difference between the Pupil-teacher ratio(headcount basis) of Cabo Verde and Pupil-teacher ratio(headcount basis) of Nigeria?
Your answer should be compact. -9.42. In the year 2007, what is the difference between the Pupil-teacher ratio(headcount basis) of Chile and Pupil-teacher ratio(headcount basis) of Nigeria?
Make the answer very short. -4.73. In the year 2008, what is the difference between the Pupil-teacher ratio(headcount basis) in South Asia and Pupil-teacher ratio(headcount basis) in Cabo Verde?
Your answer should be compact. 8.02. In the year 2008, what is the difference between the Pupil-teacher ratio(headcount basis) in South Asia and Pupil-teacher ratio(headcount basis) in Chile?
Keep it short and to the point. 2.94. In the year 2008, what is the difference between the Pupil-teacher ratio(headcount basis) of South Asia and Pupil-teacher ratio(headcount basis) of Nigeria?
Your answer should be very brief. 3.92. In the year 2008, what is the difference between the Pupil-teacher ratio(headcount basis) of Cabo Verde and Pupil-teacher ratio(headcount basis) of Chile?
Offer a very short reply. -5.08. In the year 2008, what is the difference between the Pupil-teacher ratio(headcount basis) of Cabo Verde and Pupil-teacher ratio(headcount basis) of Nigeria?
Ensure brevity in your answer.  -4.1. In the year 2008, what is the difference between the Pupil-teacher ratio(headcount basis) in Chile and Pupil-teacher ratio(headcount basis) in Nigeria?
Your response must be concise. 0.98. In the year 2010, what is the difference between the Pupil-teacher ratio(headcount basis) in South Asia and Pupil-teacher ratio(headcount basis) in Cabo Verde?
Provide a short and direct response. 7.7. In the year 2010, what is the difference between the Pupil-teacher ratio(headcount basis) of South Asia and Pupil-teacher ratio(headcount basis) of Chile?
Provide a short and direct response. 3.35. In the year 2010, what is the difference between the Pupil-teacher ratio(headcount basis) of South Asia and Pupil-teacher ratio(headcount basis) of Nigeria?
Provide a short and direct response. -7.87. In the year 2010, what is the difference between the Pupil-teacher ratio(headcount basis) of Cabo Verde and Pupil-teacher ratio(headcount basis) of Chile?
Keep it short and to the point. -4.35. In the year 2010, what is the difference between the Pupil-teacher ratio(headcount basis) in Cabo Verde and Pupil-teacher ratio(headcount basis) in Nigeria?
Make the answer very short. -15.57. In the year 2010, what is the difference between the Pupil-teacher ratio(headcount basis) of Chile and Pupil-teacher ratio(headcount basis) of Nigeria?
Keep it short and to the point. -11.21. What is the ratio of the Pupil-teacher ratio(headcount basis) of South Asia in 2004 to that in 2005?
Keep it short and to the point. 1.06. What is the ratio of the Pupil-teacher ratio(headcount basis) in Chile in 2004 to that in 2005?
Ensure brevity in your answer.  1.02. What is the ratio of the Pupil-teacher ratio(headcount basis) of Nigeria in 2004 to that in 2005?
Keep it short and to the point. 1.01. What is the ratio of the Pupil-teacher ratio(headcount basis) in South Asia in 2004 to that in 2006?
Provide a short and direct response. 1.1. What is the ratio of the Pupil-teacher ratio(headcount basis) of Cabo Verde in 2004 to that in 2006?
Your answer should be compact. 0.87. What is the ratio of the Pupil-teacher ratio(headcount basis) in Chile in 2004 to that in 2006?
Offer a terse response. 1.03. What is the ratio of the Pupil-teacher ratio(headcount basis) in Nigeria in 2004 to that in 2006?
Give a very brief answer. 1.28. What is the ratio of the Pupil-teacher ratio(headcount basis) in South Asia in 2004 to that in 2007?
Your answer should be compact. 1.14. What is the ratio of the Pupil-teacher ratio(headcount basis) of Cabo Verde in 2004 to that in 2007?
Ensure brevity in your answer.  1.19. What is the ratio of the Pupil-teacher ratio(headcount basis) in Chile in 2004 to that in 2007?
Make the answer very short. 1.06. What is the ratio of the Pupil-teacher ratio(headcount basis) in Nigeria in 2004 to that in 2007?
Your answer should be very brief. 1.43. What is the ratio of the Pupil-teacher ratio(headcount basis) of South Asia in 2004 to that in 2008?
Ensure brevity in your answer.  1.19. What is the ratio of the Pupil-teacher ratio(headcount basis) of Cabo Verde in 2004 to that in 2008?
Keep it short and to the point. 1.24. What is the ratio of the Pupil-teacher ratio(headcount basis) in Nigeria in 2004 to that in 2008?
Offer a very short reply. 1.82. What is the ratio of the Pupil-teacher ratio(headcount basis) of South Asia in 2004 to that in 2010?
Keep it short and to the point. 1.24. What is the ratio of the Pupil-teacher ratio(headcount basis) of Cabo Verde in 2004 to that in 2010?
Offer a very short reply. 1.3. What is the ratio of the Pupil-teacher ratio(headcount basis) in Chile in 2004 to that in 2010?
Provide a succinct answer. 1.15. What is the ratio of the Pupil-teacher ratio(headcount basis) in Nigeria in 2004 to that in 2010?
Offer a terse response. 1.23. What is the ratio of the Pupil-teacher ratio(headcount basis) of South Asia in 2005 to that in 2006?
Keep it short and to the point. 1.04. What is the ratio of the Pupil-teacher ratio(headcount basis) in Cabo Verde in 2005 to that in 2006?
Make the answer very short. 0.9. What is the ratio of the Pupil-teacher ratio(headcount basis) of Chile in 2005 to that in 2006?
Offer a terse response. 1.01. What is the ratio of the Pupil-teacher ratio(headcount basis) of Nigeria in 2005 to that in 2006?
Make the answer very short. 1.26. What is the ratio of the Pupil-teacher ratio(headcount basis) in South Asia in 2005 to that in 2007?
Your answer should be very brief. 1.08. What is the ratio of the Pupil-teacher ratio(headcount basis) in Cabo Verde in 2005 to that in 2007?
Keep it short and to the point. 1.24. What is the ratio of the Pupil-teacher ratio(headcount basis) of Chile in 2005 to that in 2007?
Keep it short and to the point. 1.04. What is the ratio of the Pupil-teacher ratio(headcount basis) of Nigeria in 2005 to that in 2007?
Provide a short and direct response. 1.41. What is the ratio of the Pupil-teacher ratio(headcount basis) of South Asia in 2005 to that in 2008?
Provide a succinct answer. 1.12. What is the ratio of the Pupil-teacher ratio(headcount basis) of Cabo Verde in 2005 to that in 2008?
Your answer should be compact. 1.29. What is the ratio of the Pupil-teacher ratio(headcount basis) of Chile in 2005 to that in 2008?
Your response must be concise. 1.06. What is the ratio of the Pupil-teacher ratio(headcount basis) in Nigeria in 2005 to that in 2008?
Your answer should be compact. 1.8. What is the ratio of the Pupil-teacher ratio(headcount basis) of South Asia in 2005 to that in 2010?
Your answer should be compact. 1.17. What is the ratio of the Pupil-teacher ratio(headcount basis) of Cabo Verde in 2005 to that in 2010?
Keep it short and to the point. 1.34. What is the ratio of the Pupil-teacher ratio(headcount basis) of Chile in 2005 to that in 2010?
Keep it short and to the point. 1.13. What is the ratio of the Pupil-teacher ratio(headcount basis) in Nigeria in 2005 to that in 2010?
Keep it short and to the point. 1.21. What is the ratio of the Pupil-teacher ratio(headcount basis) in South Asia in 2006 to that in 2007?
Your answer should be very brief. 1.04. What is the ratio of the Pupil-teacher ratio(headcount basis) in Cabo Verde in 2006 to that in 2007?
Make the answer very short. 1.37. What is the ratio of the Pupil-teacher ratio(headcount basis) in Chile in 2006 to that in 2007?
Your response must be concise. 1.03. What is the ratio of the Pupil-teacher ratio(headcount basis) of Nigeria in 2006 to that in 2007?
Give a very brief answer. 1.12. What is the ratio of the Pupil-teacher ratio(headcount basis) in South Asia in 2006 to that in 2008?
Your response must be concise. 1.08. What is the ratio of the Pupil-teacher ratio(headcount basis) in Cabo Verde in 2006 to that in 2008?
Provide a short and direct response. 1.43. What is the ratio of the Pupil-teacher ratio(headcount basis) in Chile in 2006 to that in 2008?
Offer a terse response. 1.05. What is the ratio of the Pupil-teacher ratio(headcount basis) of Nigeria in 2006 to that in 2008?
Keep it short and to the point. 1.43. What is the ratio of the Pupil-teacher ratio(headcount basis) in South Asia in 2006 to that in 2010?
Provide a succinct answer. 1.12. What is the ratio of the Pupil-teacher ratio(headcount basis) of Cabo Verde in 2006 to that in 2010?
Make the answer very short. 1.49. What is the ratio of the Pupil-teacher ratio(headcount basis) in Chile in 2006 to that in 2010?
Your answer should be compact. 1.12. What is the ratio of the Pupil-teacher ratio(headcount basis) of Nigeria in 2006 to that in 2010?
Provide a short and direct response. 0.96. What is the ratio of the Pupil-teacher ratio(headcount basis) in South Asia in 2007 to that in 2008?
Offer a very short reply. 1.04. What is the ratio of the Pupil-teacher ratio(headcount basis) of Cabo Verde in 2007 to that in 2008?
Provide a short and direct response. 1.04. What is the ratio of the Pupil-teacher ratio(headcount basis) in Chile in 2007 to that in 2008?
Keep it short and to the point. 1.02. What is the ratio of the Pupil-teacher ratio(headcount basis) of Nigeria in 2007 to that in 2008?
Ensure brevity in your answer.  1.27. What is the ratio of the Pupil-teacher ratio(headcount basis) of South Asia in 2007 to that in 2010?
Your answer should be compact. 1.08. What is the ratio of the Pupil-teacher ratio(headcount basis) of Cabo Verde in 2007 to that in 2010?
Keep it short and to the point. 1.09. What is the ratio of the Pupil-teacher ratio(headcount basis) of Chile in 2007 to that in 2010?
Offer a terse response. 1.08. What is the ratio of the Pupil-teacher ratio(headcount basis) of Nigeria in 2007 to that in 2010?
Make the answer very short. 0.86. What is the ratio of the Pupil-teacher ratio(headcount basis) in South Asia in 2008 to that in 2010?
Provide a short and direct response. 1.04. What is the ratio of the Pupil-teacher ratio(headcount basis) of Cabo Verde in 2008 to that in 2010?
Give a very brief answer. 1.04. What is the ratio of the Pupil-teacher ratio(headcount basis) in Chile in 2008 to that in 2010?
Keep it short and to the point. 1.07. What is the ratio of the Pupil-teacher ratio(headcount basis) in Nigeria in 2008 to that in 2010?
Make the answer very short. 0.68. What is the difference between the highest and the second highest Pupil-teacher ratio(headcount basis) of South Asia?
Keep it short and to the point. 1.74. What is the difference between the highest and the second highest Pupil-teacher ratio(headcount basis) of Cabo Verde?
Offer a very short reply. 2.51. What is the difference between the highest and the second highest Pupil-teacher ratio(headcount basis) in Chile?
Offer a terse response. 0.42. What is the difference between the highest and the second highest Pupil-teacher ratio(headcount basis) of Nigeria?
Your answer should be compact. 0.45. What is the difference between the highest and the lowest Pupil-teacher ratio(headcount basis) of South Asia?
Provide a succinct answer. 5.93. What is the difference between the highest and the lowest Pupil-teacher ratio(headcount basis) in Cabo Verde?
Your answer should be compact. 8.5. What is the difference between the highest and the lowest Pupil-teacher ratio(headcount basis) of Chile?
Make the answer very short. 3.33. What is the difference between the highest and the lowest Pupil-teacher ratio(headcount basis) in Nigeria?
Provide a short and direct response. 18.28. 